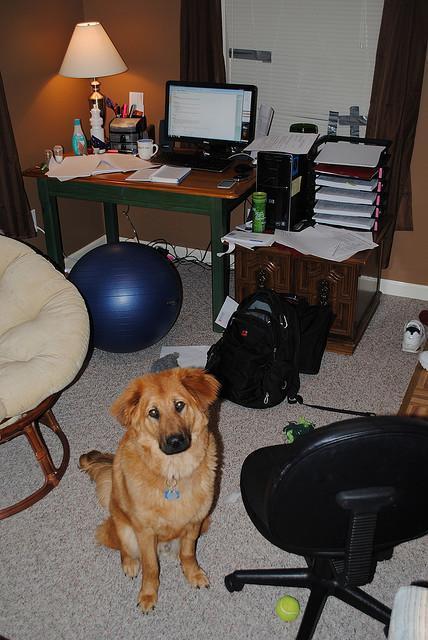How many balls do you see on the ground?
Give a very brief answer. 2. How many chairs can be seen?
Give a very brief answer. 2. How many zebra are standing in this field?
Give a very brief answer. 0. 